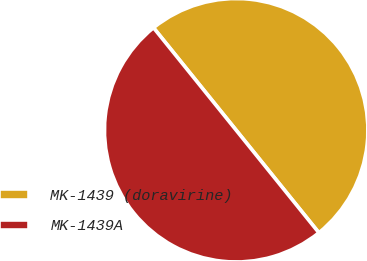Convert chart to OTSL. <chart><loc_0><loc_0><loc_500><loc_500><pie_chart><fcel>MK-1439 (doravirine)<fcel>MK-1439A<nl><fcel>50.0%<fcel>50.0%<nl></chart> 